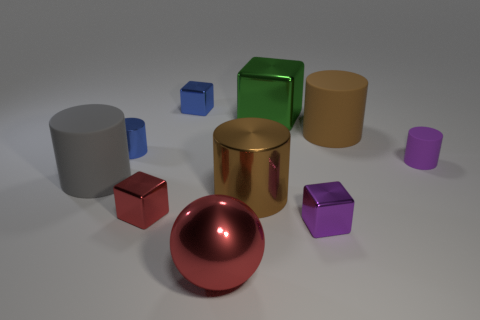Subtract all gray cylinders. How many cylinders are left? 4 Subtract all small blue metallic cylinders. How many cylinders are left? 4 Subtract all yellow cylinders. Subtract all gray blocks. How many cylinders are left? 5 Subtract all blocks. How many objects are left? 6 Add 4 big cyan matte balls. How many big cyan matte balls exist? 4 Subtract 0 gray cubes. How many objects are left? 10 Subtract all large blocks. Subtract all tiny metal cubes. How many objects are left? 6 Add 8 brown shiny things. How many brown shiny things are left? 9 